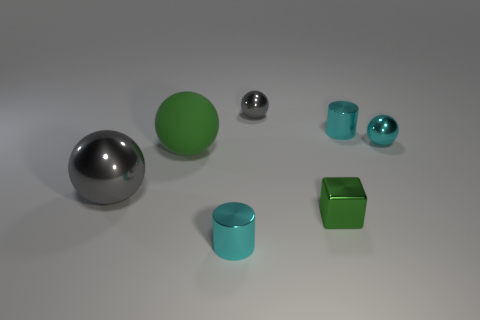There is a tiny shiny cube on the right side of the green ball; is its color the same as the rubber sphere?
Ensure brevity in your answer.  Yes. Is the color of the tiny block the same as the rubber ball?
Your response must be concise. Yes. Are there any small metal things of the same color as the matte object?
Offer a terse response. Yes. What shape is the shiny object that is the same color as the big rubber thing?
Your answer should be compact. Cube. There is a cylinder that is in front of the green sphere; is its color the same as the tiny shiny cylinder behind the small cyan metal ball?
Offer a very short reply. Yes. There is a cyan metallic cylinder behind the green cube; is its size the same as the cyan metal ball that is behind the green matte sphere?
Offer a terse response. Yes. What number of other things are there of the same size as the matte ball?
Your answer should be very brief. 1. There is a tiny cyan shiny cylinder left of the green cube; what number of things are to the left of it?
Offer a terse response. 2. Is the number of big green rubber objects that are behind the big matte sphere less than the number of large blue cylinders?
Your response must be concise. No. There is a green thing to the right of the gray thing to the right of the gray sphere in front of the large green matte object; what shape is it?
Your answer should be compact. Cube. 